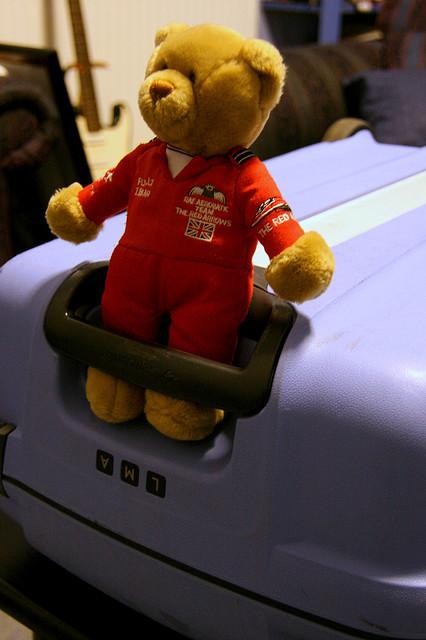Why is the bear hook up like that?
Give a very brief answer. For picture. What is the bear sitting on?
Short answer required. Suitcase. What animal is this?
Short answer required. Bear. 